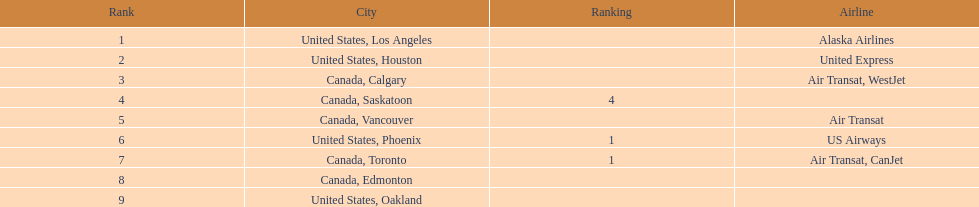Was los angeles or houston the busiest international route at manzanillo international airport in 2013? Los Angeles. 